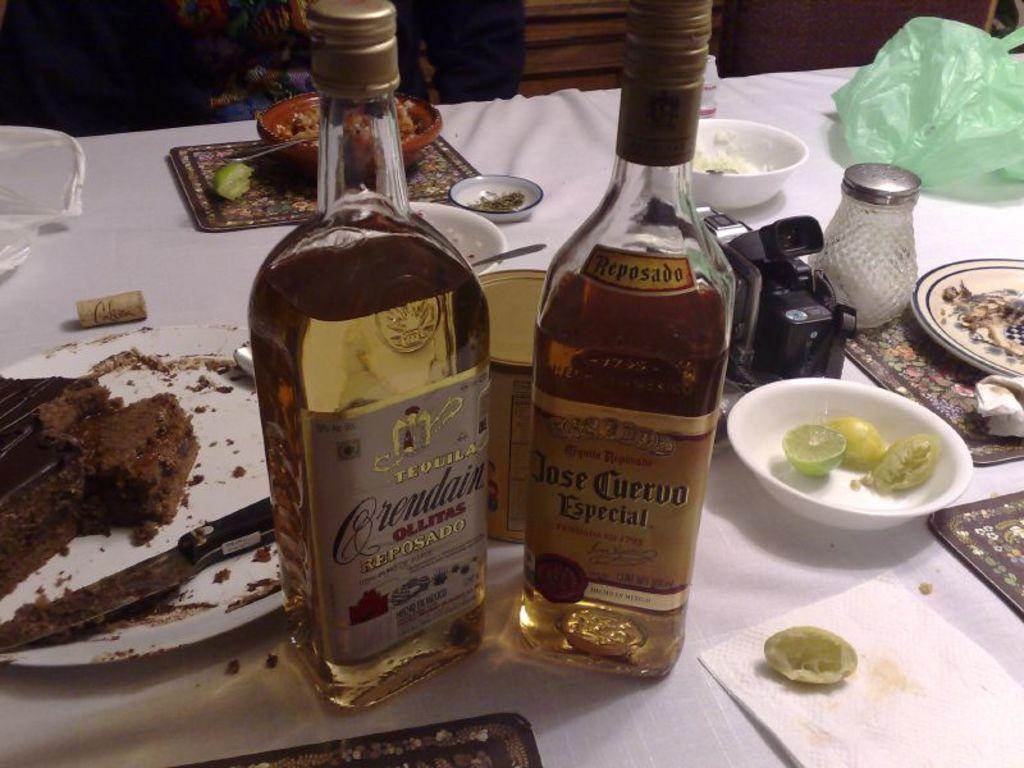What type of alcohol is in the bottles?
Offer a very short reply. Tequila. 